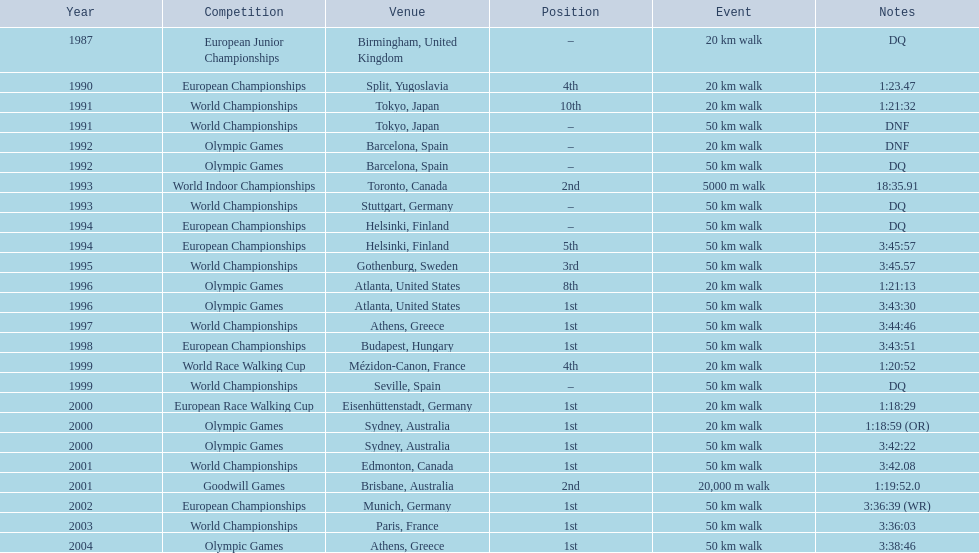What are the notes DQ, 1:23.47, 1:21:32, DNF, DNF, DQ, 18:35.91, DQ, DQ, 3:45:57, 3:45.57, 1:21:13, 3:43:30, 3:44:46, 3:43:51, 1:20:52, DQ, 1:18:29, 1:18:59 (OR), 3:42:22, 3:42.08, 1:19:52.0, 3:36:39 (WR), 3:36:03, 3:38:46. What time does the notes for 2004 show 3:38:46. 